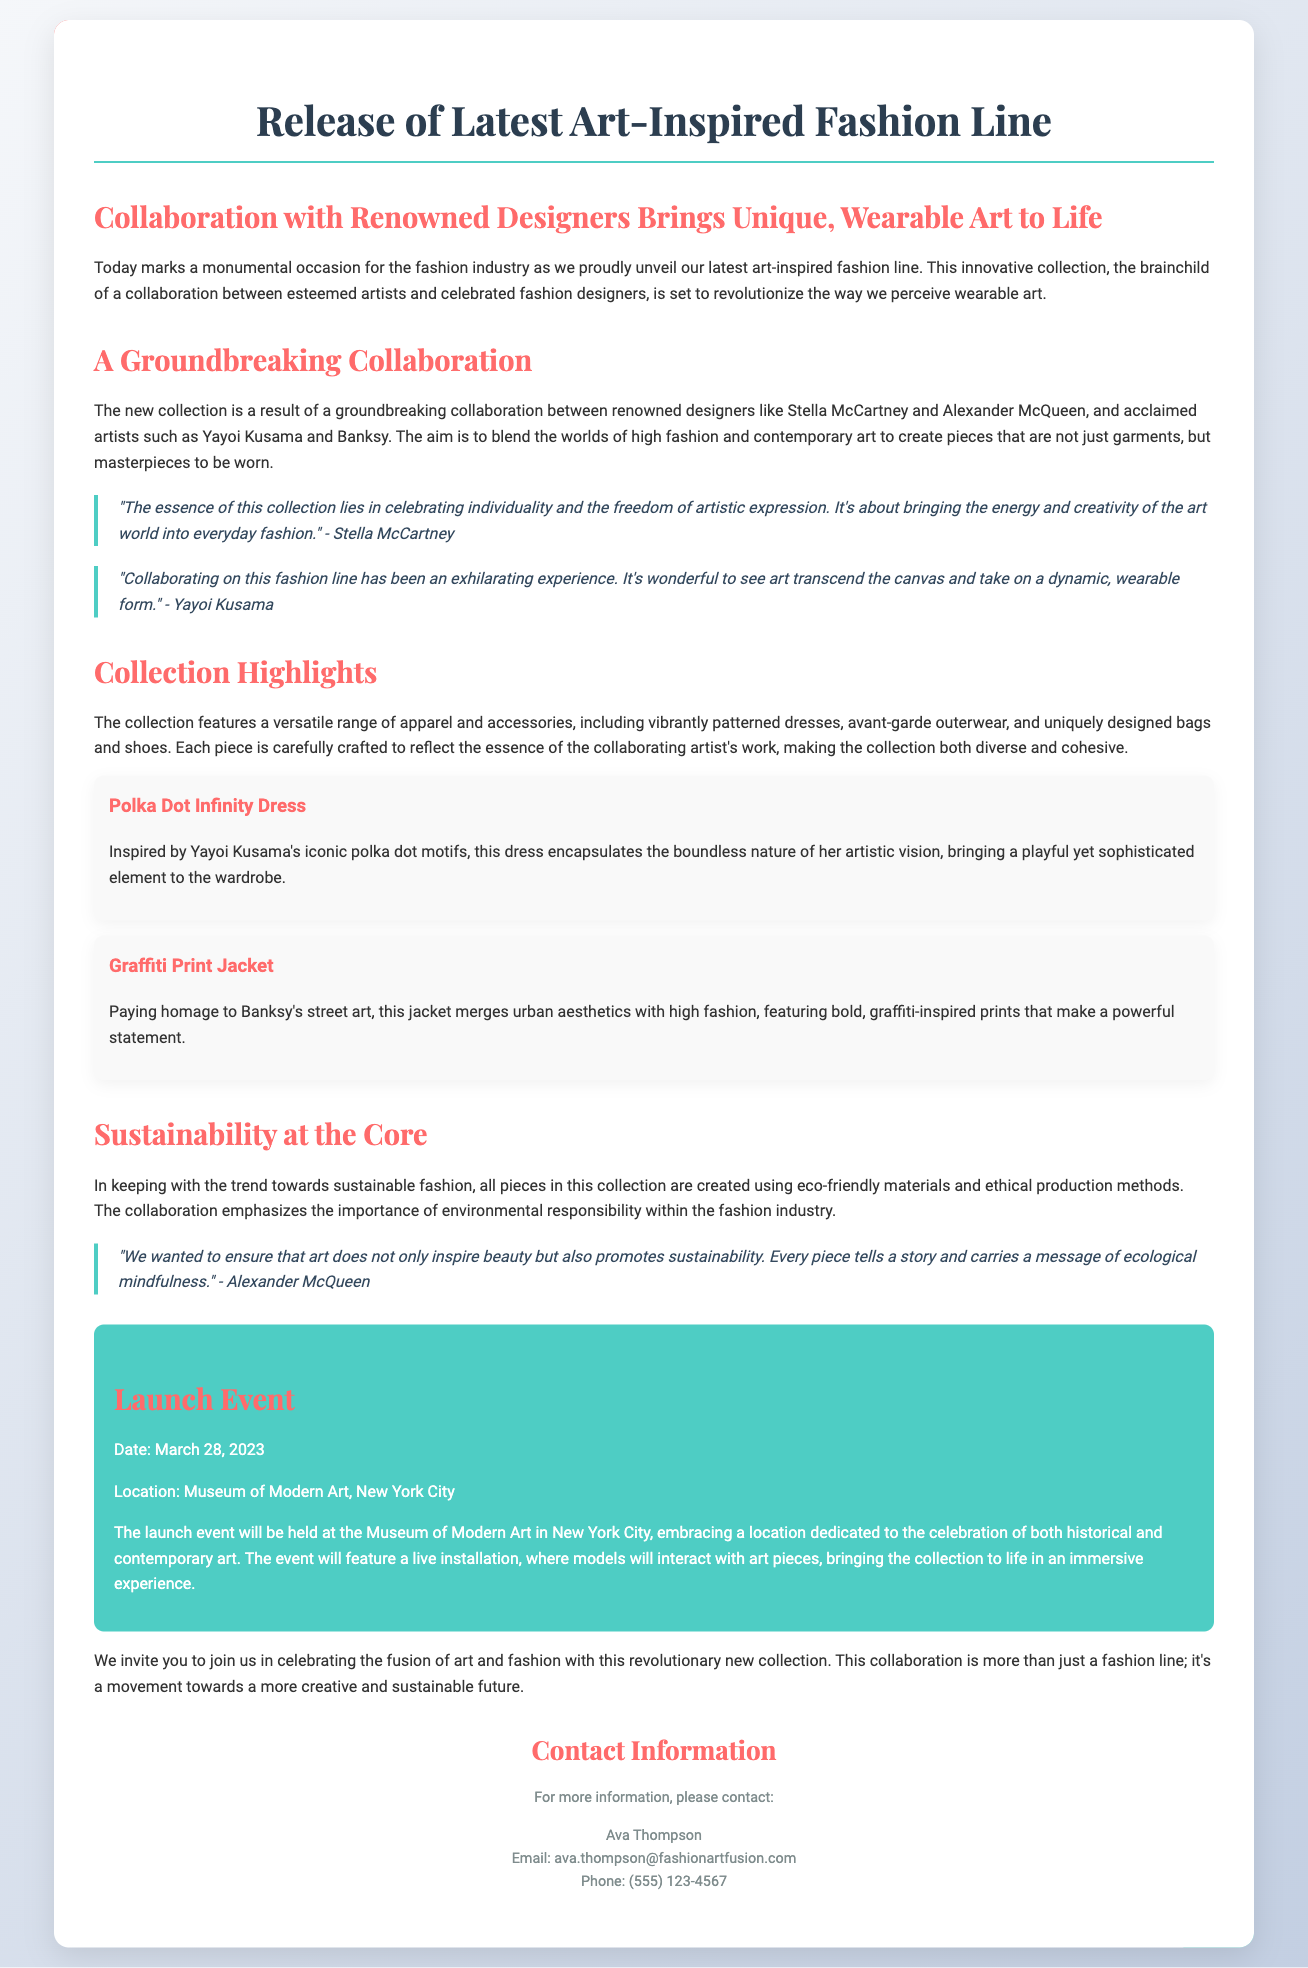What is the name of the new collection? The document introduces a new art-inspired fashion line, which is referred to as a "collection."
Answer: art-inspired fashion line Who are two of the designers involved in this collaboration? The press release mentions renowned designers Stella McCartney and Alexander McQueen as part of the collaboration.
Answer: Stella McCartney, Alexander McQueen What is the date of the launch event? The launch event is scheduled for March 28, 2023, as stated in the document.
Answer: March 28, 2023 What type of materials are used in the collection? The document states that all pieces in the collection are created using eco-friendly materials and ethical production methods.
Answer: eco-friendly materials Which artist's motifs inspired the Polka Dot Infinity Dress? The Polka Dot Infinity Dress is inspired by the motifs of Yayoi Kusama, as mentioned in the specific key piece description.
Answer: Yayoi Kusama What is the main theme emphasized in Alexander McQueen's quote? Alexander McQueen's quote emphasizes the importance of ecological mindfulness and promoting sustainability in the fashion line.
Answer: sustainability Where will the launch event take place? The press release specifies that the launch event will be held at the Museum of Modern Art in New York City.
Answer: Museum of Modern Art, New York City What is the core message of the collection according to the document? The core message of the collection revolves around celebrating individuality and the freedom of artistic expression in fashion.
Answer: individuality and freedom of artistic expression What kind of experience will the launch event feature? The launch event will include a live installation where models will interact with art pieces, creating an immersive experience.
Answer: immersive experience 